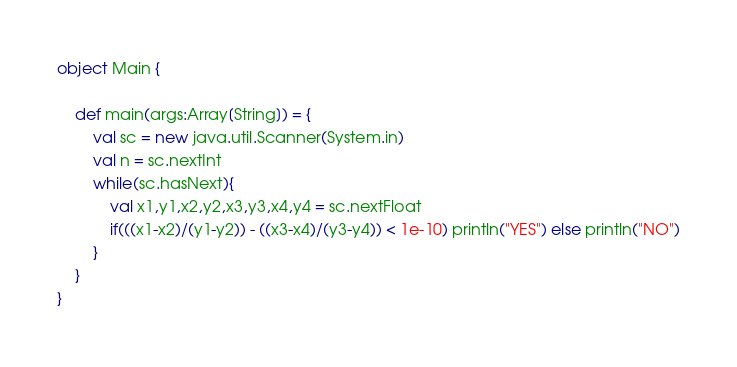<code> <loc_0><loc_0><loc_500><loc_500><_Scala_>object Main {

    def main(args:Array[String]) = {
        val sc = new java.util.Scanner(System.in)
        val n = sc.nextInt
        while(sc.hasNext){
            val x1,y1,x2,y2,x3,y3,x4,y4 = sc.nextFloat
            if(((x1-x2)/(y1-y2)) - ((x3-x4)/(y3-y4)) < 1e-10) println("YES") else println("NO")
        }
    }
}</code> 